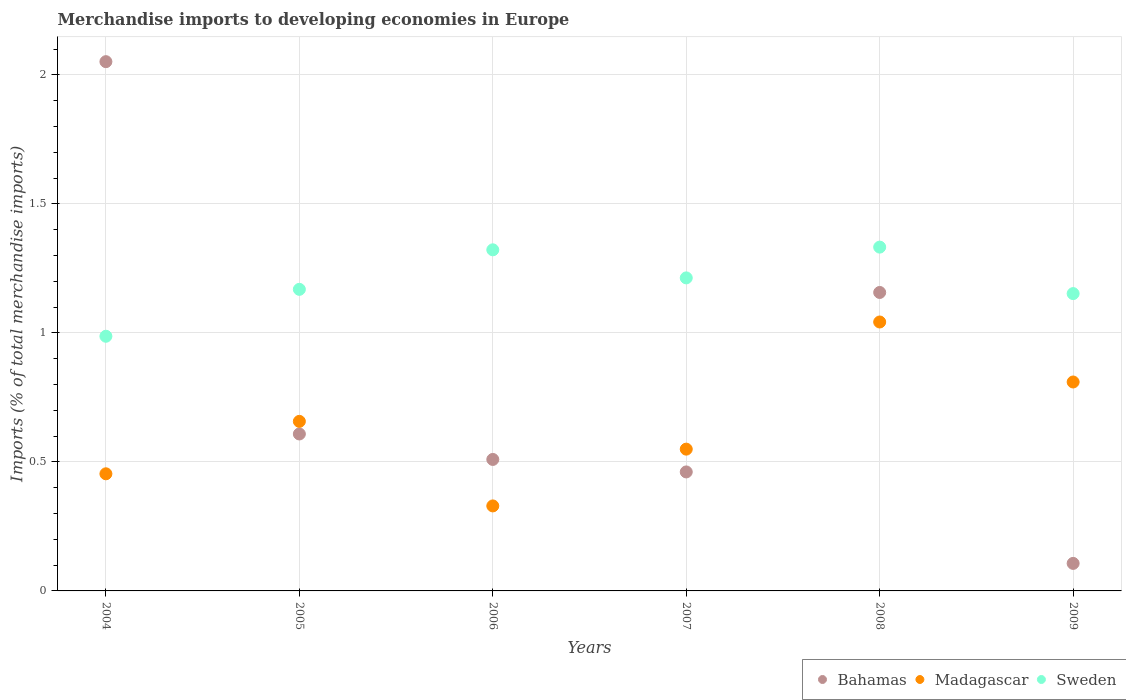Is the number of dotlines equal to the number of legend labels?
Your answer should be very brief. Yes. What is the percentage total merchandise imports in Sweden in 2007?
Provide a succinct answer. 1.21. Across all years, what is the maximum percentage total merchandise imports in Sweden?
Provide a succinct answer. 1.33. Across all years, what is the minimum percentage total merchandise imports in Bahamas?
Provide a succinct answer. 0.11. In which year was the percentage total merchandise imports in Madagascar maximum?
Give a very brief answer. 2008. What is the total percentage total merchandise imports in Madagascar in the graph?
Make the answer very short. 3.84. What is the difference between the percentage total merchandise imports in Sweden in 2007 and that in 2009?
Your answer should be compact. 0.06. What is the difference between the percentage total merchandise imports in Sweden in 2005 and the percentage total merchandise imports in Madagascar in 2007?
Offer a very short reply. 0.62. What is the average percentage total merchandise imports in Bahamas per year?
Offer a terse response. 0.82. In the year 2007, what is the difference between the percentage total merchandise imports in Sweden and percentage total merchandise imports in Bahamas?
Provide a succinct answer. 0.75. What is the ratio of the percentage total merchandise imports in Sweden in 2005 to that in 2007?
Provide a short and direct response. 0.96. Is the percentage total merchandise imports in Sweden in 2004 less than that in 2007?
Ensure brevity in your answer.  Yes. Is the difference between the percentage total merchandise imports in Sweden in 2006 and 2007 greater than the difference between the percentage total merchandise imports in Bahamas in 2006 and 2007?
Make the answer very short. Yes. What is the difference between the highest and the second highest percentage total merchandise imports in Sweden?
Your answer should be compact. 0.01. What is the difference between the highest and the lowest percentage total merchandise imports in Sweden?
Your response must be concise. 0.35. In how many years, is the percentage total merchandise imports in Madagascar greater than the average percentage total merchandise imports in Madagascar taken over all years?
Offer a terse response. 3. Is the sum of the percentage total merchandise imports in Sweden in 2005 and 2008 greater than the maximum percentage total merchandise imports in Bahamas across all years?
Your answer should be very brief. Yes. Is it the case that in every year, the sum of the percentage total merchandise imports in Madagascar and percentage total merchandise imports in Bahamas  is greater than the percentage total merchandise imports in Sweden?
Give a very brief answer. No. Does the percentage total merchandise imports in Bahamas monotonically increase over the years?
Provide a short and direct response. No. Is the percentage total merchandise imports in Sweden strictly greater than the percentage total merchandise imports in Bahamas over the years?
Your answer should be very brief. No. How many years are there in the graph?
Your answer should be compact. 6. What is the difference between two consecutive major ticks on the Y-axis?
Your response must be concise. 0.5. Are the values on the major ticks of Y-axis written in scientific E-notation?
Your answer should be very brief. No. Where does the legend appear in the graph?
Give a very brief answer. Bottom right. How many legend labels are there?
Ensure brevity in your answer.  3. How are the legend labels stacked?
Your answer should be very brief. Horizontal. What is the title of the graph?
Offer a very short reply. Merchandise imports to developing economies in Europe. Does "Bermuda" appear as one of the legend labels in the graph?
Provide a succinct answer. No. What is the label or title of the X-axis?
Offer a very short reply. Years. What is the label or title of the Y-axis?
Your answer should be compact. Imports (% of total merchandise imports). What is the Imports (% of total merchandise imports) in Bahamas in 2004?
Your response must be concise. 2.05. What is the Imports (% of total merchandise imports) of Madagascar in 2004?
Give a very brief answer. 0.45. What is the Imports (% of total merchandise imports) in Sweden in 2004?
Ensure brevity in your answer.  0.99. What is the Imports (% of total merchandise imports) of Bahamas in 2005?
Provide a short and direct response. 0.61. What is the Imports (% of total merchandise imports) of Madagascar in 2005?
Keep it short and to the point. 0.66. What is the Imports (% of total merchandise imports) of Sweden in 2005?
Ensure brevity in your answer.  1.17. What is the Imports (% of total merchandise imports) of Bahamas in 2006?
Make the answer very short. 0.51. What is the Imports (% of total merchandise imports) in Madagascar in 2006?
Keep it short and to the point. 0.33. What is the Imports (% of total merchandise imports) of Sweden in 2006?
Ensure brevity in your answer.  1.32. What is the Imports (% of total merchandise imports) of Bahamas in 2007?
Give a very brief answer. 0.46. What is the Imports (% of total merchandise imports) of Madagascar in 2007?
Give a very brief answer. 0.55. What is the Imports (% of total merchandise imports) of Sweden in 2007?
Provide a succinct answer. 1.21. What is the Imports (% of total merchandise imports) in Bahamas in 2008?
Offer a very short reply. 1.16. What is the Imports (% of total merchandise imports) in Madagascar in 2008?
Offer a very short reply. 1.04. What is the Imports (% of total merchandise imports) of Sweden in 2008?
Offer a very short reply. 1.33. What is the Imports (% of total merchandise imports) of Bahamas in 2009?
Offer a terse response. 0.11. What is the Imports (% of total merchandise imports) of Madagascar in 2009?
Your answer should be compact. 0.81. What is the Imports (% of total merchandise imports) in Sweden in 2009?
Your answer should be compact. 1.15. Across all years, what is the maximum Imports (% of total merchandise imports) of Bahamas?
Give a very brief answer. 2.05. Across all years, what is the maximum Imports (% of total merchandise imports) in Madagascar?
Offer a terse response. 1.04. Across all years, what is the maximum Imports (% of total merchandise imports) of Sweden?
Your response must be concise. 1.33. Across all years, what is the minimum Imports (% of total merchandise imports) of Bahamas?
Your answer should be very brief. 0.11. Across all years, what is the minimum Imports (% of total merchandise imports) of Madagascar?
Ensure brevity in your answer.  0.33. Across all years, what is the minimum Imports (% of total merchandise imports) of Sweden?
Provide a short and direct response. 0.99. What is the total Imports (% of total merchandise imports) of Bahamas in the graph?
Offer a very short reply. 4.89. What is the total Imports (% of total merchandise imports) in Madagascar in the graph?
Provide a succinct answer. 3.84. What is the total Imports (% of total merchandise imports) in Sweden in the graph?
Your response must be concise. 7.18. What is the difference between the Imports (% of total merchandise imports) in Bahamas in 2004 and that in 2005?
Provide a short and direct response. 1.44. What is the difference between the Imports (% of total merchandise imports) of Madagascar in 2004 and that in 2005?
Keep it short and to the point. -0.2. What is the difference between the Imports (% of total merchandise imports) in Sweden in 2004 and that in 2005?
Offer a very short reply. -0.18. What is the difference between the Imports (% of total merchandise imports) of Bahamas in 2004 and that in 2006?
Ensure brevity in your answer.  1.54. What is the difference between the Imports (% of total merchandise imports) in Madagascar in 2004 and that in 2006?
Make the answer very short. 0.12. What is the difference between the Imports (% of total merchandise imports) of Sweden in 2004 and that in 2006?
Make the answer very short. -0.34. What is the difference between the Imports (% of total merchandise imports) in Bahamas in 2004 and that in 2007?
Provide a short and direct response. 1.59. What is the difference between the Imports (% of total merchandise imports) in Madagascar in 2004 and that in 2007?
Your answer should be very brief. -0.1. What is the difference between the Imports (% of total merchandise imports) in Sweden in 2004 and that in 2007?
Provide a short and direct response. -0.23. What is the difference between the Imports (% of total merchandise imports) of Bahamas in 2004 and that in 2008?
Offer a very short reply. 0.89. What is the difference between the Imports (% of total merchandise imports) of Madagascar in 2004 and that in 2008?
Offer a very short reply. -0.59. What is the difference between the Imports (% of total merchandise imports) in Sweden in 2004 and that in 2008?
Keep it short and to the point. -0.35. What is the difference between the Imports (% of total merchandise imports) in Bahamas in 2004 and that in 2009?
Provide a short and direct response. 1.94. What is the difference between the Imports (% of total merchandise imports) of Madagascar in 2004 and that in 2009?
Your answer should be very brief. -0.36. What is the difference between the Imports (% of total merchandise imports) in Sweden in 2004 and that in 2009?
Offer a terse response. -0.17. What is the difference between the Imports (% of total merchandise imports) in Bahamas in 2005 and that in 2006?
Offer a very short reply. 0.1. What is the difference between the Imports (% of total merchandise imports) of Madagascar in 2005 and that in 2006?
Your answer should be compact. 0.33. What is the difference between the Imports (% of total merchandise imports) of Sweden in 2005 and that in 2006?
Give a very brief answer. -0.15. What is the difference between the Imports (% of total merchandise imports) of Bahamas in 2005 and that in 2007?
Your answer should be compact. 0.15. What is the difference between the Imports (% of total merchandise imports) in Madagascar in 2005 and that in 2007?
Your answer should be very brief. 0.11. What is the difference between the Imports (% of total merchandise imports) of Sweden in 2005 and that in 2007?
Offer a very short reply. -0.04. What is the difference between the Imports (% of total merchandise imports) in Bahamas in 2005 and that in 2008?
Provide a succinct answer. -0.55. What is the difference between the Imports (% of total merchandise imports) in Madagascar in 2005 and that in 2008?
Your answer should be compact. -0.39. What is the difference between the Imports (% of total merchandise imports) of Sweden in 2005 and that in 2008?
Your response must be concise. -0.16. What is the difference between the Imports (% of total merchandise imports) in Bahamas in 2005 and that in 2009?
Your answer should be compact. 0.5. What is the difference between the Imports (% of total merchandise imports) in Madagascar in 2005 and that in 2009?
Offer a terse response. -0.15. What is the difference between the Imports (% of total merchandise imports) of Sweden in 2005 and that in 2009?
Your response must be concise. 0.02. What is the difference between the Imports (% of total merchandise imports) in Bahamas in 2006 and that in 2007?
Offer a very short reply. 0.05. What is the difference between the Imports (% of total merchandise imports) of Madagascar in 2006 and that in 2007?
Your answer should be compact. -0.22. What is the difference between the Imports (% of total merchandise imports) of Sweden in 2006 and that in 2007?
Offer a very short reply. 0.11. What is the difference between the Imports (% of total merchandise imports) in Bahamas in 2006 and that in 2008?
Give a very brief answer. -0.65. What is the difference between the Imports (% of total merchandise imports) of Madagascar in 2006 and that in 2008?
Your response must be concise. -0.71. What is the difference between the Imports (% of total merchandise imports) of Sweden in 2006 and that in 2008?
Provide a succinct answer. -0.01. What is the difference between the Imports (% of total merchandise imports) in Bahamas in 2006 and that in 2009?
Provide a short and direct response. 0.4. What is the difference between the Imports (% of total merchandise imports) of Madagascar in 2006 and that in 2009?
Offer a terse response. -0.48. What is the difference between the Imports (% of total merchandise imports) in Sweden in 2006 and that in 2009?
Offer a terse response. 0.17. What is the difference between the Imports (% of total merchandise imports) of Bahamas in 2007 and that in 2008?
Provide a short and direct response. -0.7. What is the difference between the Imports (% of total merchandise imports) in Madagascar in 2007 and that in 2008?
Ensure brevity in your answer.  -0.49. What is the difference between the Imports (% of total merchandise imports) in Sweden in 2007 and that in 2008?
Your answer should be very brief. -0.12. What is the difference between the Imports (% of total merchandise imports) in Bahamas in 2007 and that in 2009?
Your answer should be very brief. 0.35. What is the difference between the Imports (% of total merchandise imports) in Madagascar in 2007 and that in 2009?
Give a very brief answer. -0.26. What is the difference between the Imports (% of total merchandise imports) of Sweden in 2007 and that in 2009?
Offer a very short reply. 0.06. What is the difference between the Imports (% of total merchandise imports) of Bahamas in 2008 and that in 2009?
Provide a succinct answer. 1.05. What is the difference between the Imports (% of total merchandise imports) of Madagascar in 2008 and that in 2009?
Your answer should be very brief. 0.23. What is the difference between the Imports (% of total merchandise imports) in Sweden in 2008 and that in 2009?
Your response must be concise. 0.18. What is the difference between the Imports (% of total merchandise imports) in Bahamas in 2004 and the Imports (% of total merchandise imports) in Madagascar in 2005?
Provide a succinct answer. 1.39. What is the difference between the Imports (% of total merchandise imports) of Bahamas in 2004 and the Imports (% of total merchandise imports) of Sweden in 2005?
Offer a terse response. 0.88. What is the difference between the Imports (% of total merchandise imports) in Madagascar in 2004 and the Imports (% of total merchandise imports) in Sweden in 2005?
Provide a succinct answer. -0.71. What is the difference between the Imports (% of total merchandise imports) in Bahamas in 2004 and the Imports (% of total merchandise imports) in Madagascar in 2006?
Your response must be concise. 1.72. What is the difference between the Imports (% of total merchandise imports) in Bahamas in 2004 and the Imports (% of total merchandise imports) in Sweden in 2006?
Your response must be concise. 0.73. What is the difference between the Imports (% of total merchandise imports) of Madagascar in 2004 and the Imports (% of total merchandise imports) of Sweden in 2006?
Provide a short and direct response. -0.87. What is the difference between the Imports (% of total merchandise imports) in Bahamas in 2004 and the Imports (% of total merchandise imports) in Madagascar in 2007?
Provide a short and direct response. 1.5. What is the difference between the Imports (% of total merchandise imports) in Bahamas in 2004 and the Imports (% of total merchandise imports) in Sweden in 2007?
Provide a short and direct response. 0.84. What is the difference between the Imports (% of total merchandise imports) of Madagascar in 2004 and the Imports (% of total merchandise imports) of Sweden in 2007?
Your response must be concise. -0.76. What is the difference between the Imports (% of total merchandise imports) of Bahamas in 2004 and the Imports (% of total merchandise imports) of Madagascar in 2008?
Provide a succinct answer. 1.01. What is the difference between the Imports (% of total merchandise imports) of Bahamas in 2004 and the Imports (% of total merchandise imports) of Sweden in 2008?
Ensure brevity in your answer.  0.72. What is the difference between the Imports (% of total merchandise imports) of Madagascar in 2004 and the Imports (% of total merchandise imports) of Sweden in 2008?
Provide a short and direct response. -0.88. What is the difference between the Imports (% of total merchandise imports) in Bahamas in 2004 and the Imports (% of total merchandise imports) in Madagascar in 2009?
Provide a succinct answer. 1.24. What is the difference between the Imports (% of total merchandise imports) of Bahamas in 2004 and the Imports (% of total merchandise imports) of Sweden in 2009?
Offer a very short reply. 0.9. What is the difference between the Imports (% of total merchandise imports) in Madagascar in 2004 and the Imports (% of total merchandise imports) in Sweden in 2009?
Make the answer very short. -0.7. What is the difference between the Imports (% of total merchandise imports) in Bahamas in 2005 and the Imports (% of total merchandise imports) in Madagascar in 2006?
Ensure brevity in your answer.  0.28. What is the difference between the Imports (% of total merchandise imports) of Bahamas in 2005 and the Imports (% of total merchandise imports) of Sweden in 2006?
Your answer should be compact. -0.71. What is the difference between the Imports (% of total merchandise imports) of Madagascar in 2005 and the Imports (% of total merchandise imports) of Sweden in 2006?
Make the answer very short. -0.66. What is the difference between the Imports (% of total merchandise imports) in Bahamas in 2005 and the Imports (% of total merchandise imports) in Madagascar in 2007?
Offer a very short reply. 0.06. What is the difference between the Imports (% of total merchandise imports) of Bahamas in 2005 and the Imports (% of total merchandise imports) of Sweden in 2007?
Provide a short and direct response. -0.6. What is the difference between the Imports (% of total merchandise imports) in Madagascar in 2005 and the Imports (% of total merchandise imports) in Sweden in 2007?
Make the answer very short. -0.56. What is the difference between the Imports (% of total merchandise imports) in Bahamas in 2005 and the Imports (% of total merchandise imports) in Madagascar in 2008?
Offer a terse response. -0.43. What is the difference between the Imports (% of total merchandise imports) in Bahamas in 2005 and the Imports (% of total merchandise imports) in Sweden in 2008?
Your answer should be compact. -0.72. What is the difference between the Imports (% of total merchandise imports) of Madagascar in 2005 and the Imports (% of total merchandise imports) of Sweden in 2008?
Your response must be concise. -0.68. What is the difference between the Imports (% of total merchandise imports) of Bahamas in 2005 and the Imports (% of total merchandise imports) of Madagascar in 2009?
Ensure brevity in your answer.  -0.2. What is the difference between the Imports (% of total merchandise imports) of Bahamas in 2005 and the Imports (% of total merchandise imports) of Sweden in 2009?
Your answer should be very brief. -0.54. What is the difference between the Imports (% of total merchandise imports) in Madagascar in 2005 and the Imports (% of total merchandise imports) in Sweden in 2009?
Your answer should be compact. -0.5. What is the difference between the Imports (% of total merchandise imports) in Bahamas in 2006 and the Imports (% of total merchandise imports) in Madagascar in 2007?
Your answer should be very brief. -0.04. What is the difference between the Imports (% of total merchandise imports) of Bahamas in 2006 and the Imports (% of total merchandise imports) of Sweden in 2007?
Make the answer very short. -0.7. What is the difference between the Imports (% of total merchandise imports) in Madagascar in 2006 and the Imports (% of total merchandise imports) in Sweden in 2007?
Make the answer very short. -0.88. What is the difference between the Imports (% of total merchandise imports) of Bahamas in 2006 and the Imports (% of total merchandise imports) of Madagascar in 2008?
Ensure brevity in your answer.  -0.53. What is the difference between the Imports (% of total merchandise imports) in Bahamas in 2006 and the Imports (% of total merchandise imports) in Sweden in 2008?
Provide a succinct answer. -0.82. What is the difference between the Imports (% of total merchandise imports) in Madagascar in 2006 and the Imports (% of total merchandise imports) in Sweden in 2008?
Ensure brevity in your answer.  -1. What is the difference between the Imports (% of total merchandise imports) in Bahamas in 2006 and the Imports (% of total merchandise imports) in Madagascar in 2009?
Your answer should be compact. -0.3. What is the difference between the Imports (% of total merchandise imports) in Bahamas in 2006 and the Imports (% of total merchandise imports) in Sweden in 2009?
Ensure brevity in your answer.  -0.64. What is the difference between the Imports (% of total merchandise imports) of Madagascar in 2006 and the Imports (% of total merchandise imports) of Sweden in 2009?
Provide a succinct answer. -0.82. What is the difference between the Imports (% of total merchandise imports) of Bahamas in 2007 and the Imports (% of total merchandise imports) of Madagascar in 2008?
Offer a terse response. -0.58. What is the difference between the Imports (% of total merchandise imports) in Bahamas in 2007 and the Imports (% of total merchandise imports) in Sweden in 2008?
Offer a terse response. -0.87. What is the difference between the Imports (% of total merchandise imports) in Madagascar in 2007 and the Imports (% of total merchandise imports) in Sweden in 2008?
Offer a terse response. -0.78. What is the difference between the Imports (% of total merchandise imports) in Bahamas in 2007 and the Imports (% of total merchandise imports) in Madagascar in 2009?
Provide a succinct answer. -0.35. What is the difference between the Imports (% of total merchandise imports) in Bahamas in 2007 and the Imports (% of total merchandise imports) in Sweden in 2009?
Your answer should be compact. -0.69. What is the difference between the Imports (% of total merchandise imports) in Madagascar in 2007 and the Imports (% of total merchandise imports) in Sweden in 2009?
Keep it short and to the point. -0.6. What is the difference between the Imports (% of total merchandise imports) of Bahamas in 2008 and the Imports (% of total merchandise imports) of Madagascar in 2009?
Provide a short and direct response. 0.35. What is the difference between the Imports (% of total merchandise imports) in Bahamas in 2008 and the Imports (% of total merchandise imports) in Sweden in 2009?
Provide a succinct answer. 0. What is the difference between the Imports (% of total merchandise imports) in Madagascar in 2008 and the Imports (% of total merchandise imports) in Sweden in 2009?
Provide a short and direct response. -0.11. What is the average Imports (% of total merchandise imports) in Bahamas per year?
Offer a terse response. 0.82. What is the average Imports (% of total merchandise imports) of Madagascar per year?
Your answer should be very brief. 0.64. What is the average Imports (% of total merchandise imports) in Sweden per year?
Provide a succinct answer. 1.2. In the year 2004, what is the difference between the Imports (% of total merchandise imports) of Bahamas and Imports (% of total merchandise imports) of Madagascar?
Offer a terse response. 1.6. In the year 2004, what is the difference between the Imports (% of total merchandise imports) of Bahamas and Imports (% of total merchandise imports) of Sweden?
Offer a very short reply. 1.06. In the year 2004, what is the difference between the Imports (% of total merchandise imports) in Madagascar and Imports (% of total merchandise imports) in Sweden?
Offer a terse response. -0.53. In the year 2005, what is the difference between the Imports (% of total merchandise imports) in Bahamas and Imports (% of total merchandise imports) in Madagascar?
Offer a terse response. -0.05. In the year 2005, what is the difference between the Imports (% of total merchandise imports) of Bahamas and Imports (% of total merchandise imports) of Sweden?
Your answer should be very brief. -0.56. In the year 2005, what is the difference between the Imports (% of total merchandise imports) of Madagascar and Imports (% of total merchandise imports) of Sweden?
Your response must be concise. -0.51. In the year 2006, what is the difference between the Imports (% of total merchandise imports) in Bahamas and Imports (% of total merchandise imports) in Madagascar?
Your answer should be very brief. 0.18. In the year 2006, what is the difference between the Imports (% of total merchandise imports) in Bahamas and Imports (% of total merchandise imports) in Sweden?
Keep it short and to the point. -0.81. In the year 2006, what is the difference between the Imports (% of total merchandise imports) of Madagascar and Imports (% of total merchandise imports) of Sweden?
Give a very brief answer. -0.99. In the year 2007, what is the difference between the Imports (% of total merchandise imports) of Bahamas and Imports (% of total merchandise imports) of Madagascar?
Your response must be concise. -0.09. In the year 2007, what is the difference between the Imports (% of total merchandise imports) of Bahamas and Imports (% of total merchandise imports) of Sweden?
Ensure brevity in your answer.  -0.75. In the year 2007, what is the difference between the Imports (% of total merchandise imports) in Madagascar and Imports (% of total merchandise imports) in Sweden?
Provide a succinct answer. -0.66. In the year 2008, what is the difference between the Imports (% of total merchandise imports) in Bahamas and Imports (% of total merchandise imports) in Madagascar?
Your answer should be compact. 0.11. In the year 2008, what is the difference between the Imports (% of total merchandise imports) in Bahamas and Imports (% of total merchandise imports) in Sweden?
Make the answer very short. -0.18. In the year 2008, what is the difference between the Imports (% of total merchandise imports) in Madagascar and Imports (% of total merchandise imports) in Sweden?
Make the answer very short. -0.29. In the year 2009, what is the difference between the Imports (% of total merchandise imports) in Bahamas and Imports (% of total merchandise imports) in Madagascar?
Keep it short and to the point. -0.7. In the year 2009, what is the difference between the Imports (% of total merchandise imports) of Bahamas and Imports (% of total merchandise imports) of Sweden?
Provide a succinct answer. -1.05. In the year 2009, what is the difference between the Imports (% of total merchandise imports) in Madagascar and Imports (% of total merchandise imports) in Sweden?
Provide a succinct answer. -0.34. What is the ratio of the Imports (% of total merchandise imports) of Bahamas in 2004 to that in 2005?
Make the answer very short. 3.37. What is the ratio of the Imports (% of total merchandise imports) in Madagascar in 2004 to that in 2005?
Offer a terse response. 0.69. What is the ratio of the Imports (% of total merchandise imports) in Sweden in 2004 to that in 2005?
Your response must be concise. 0.84. What is the ratio of the Imports (% of total merchandise imports) of Bahamas in 2004 to that in 2006?
Ensure brevity in your answer.  4.03. What is the ratio of the Imports (% of total merchandise imports) in Madagascar in 2004 to that in 2006?
Offer a very short reply. 1.38. What is the ratio of the Imports (% of total merchandise imports) in Sweden in 2004 to that in 2006?
Offer a very short reply. 0.75. What is the ratio of the Imports (% of total merchandise imports) of Bahamas in 2004 to that in 2007?
Give a very brief answer. 4.45. What is the ratio of the Imports (% of total merchandise imports) of Madagascar in 2004 to that in 2007?
Provide a succinct answer. 0.83. What is the ratio of the Imports (% of total merchandise imports) of Sweden in 2004 to that in 2007?
Keep it short and to the point. 0.81. What is the ratio of the Imports (% of total merchandise imports) in Bahamas in 2004 to that in 2008?
Offer a terse response. 1.77. What is the ratio of the Imports (% of total merchandise imports) in Madagascar in 2004 to that in 2008?
Your answer should be compact. 0.44. What is the ratio of the Imports (% of total merchandise imports) in Sweden in 2004 to that in 2008?
Provide a short and direct response. 0.74. What is the ratio of the Imports (% of total merchandise imports) in Bahamas in 2004 to that in 2009?
Give a very brief answer. 19.23. What is the ratio of the Imports (% of total merchandise imports) of Madagascar in 2004 to that in 2009?
Provide a short and direct response. 0.56. What is the ratio of the Imports (% of total merchandise imports) in Sweden in 2004 to that in 2009?
Your answer should be very brief. 0.86. What is the ratio of the Imports (% of total merchandise imports) of Bahamas in 2005 to that in 2006?
Your answer should be compact. 1.19. What is the ratio of the Imports (% of total merchandise imports) in Madagascar in 2005 to that in 2006?
Provide a succinct answer. 1.99. What is the ratio of the Imports (% of total merchandise imports) in Sweden in 2005 to that in 2006?
Your answer should be compact. 0.88. What is the ratio of the Imports (% of total merchandise imports) of Bahamas in 2005 to that in 2007?
Keep it short and to the point. 1.32. What is the ratio of the Imports (% of total merchandise imports) of Madagascar in 2005 to that in 2007?
Your response must be concise. 1.2. What is the ratio of the Imports (% of total merchandise imports) of Sweden in 2005 to that in 2007?
Make the answer very short. 0.96. What is the ratio of the Imports (% of total merchandise imports) of Bahamas in 2005 to that in 2008?
Your answer should be compact. 0.53. What is the ratio of the Imports (% of total merchandise imports) of Madagascar in 2005 to that in 2008?
Offer a very short reply. 0.63. What is the ratio of the Imports (% of total merchandise imports) of Sweden in 2005 to that in 2008?
Give a very brief answer. 0.88. What is the ratio of the Imports (% of total merchandise imports) in Bahamas in 2005 to that in 2009?
Ensure brevity in your answer.  5.7. What is the ratio of the Imports (% of total merchandise imports) of Madagascar in 2005 to that in 2009?
Keep it short and to the point. 0.81. What is the ratio of the Imports (% of total merchandise imports) in Sweden in 2005 to that in 2009?
Provide a succinct answer. 1.01. What is the ratio of the Imports (% of total merchandise imports) in Bahamas in 2006 to that in 2007?
Make the answer very short. 1.1. What is the ratio of the Imports (% of total merchandise imports) in Madagascar in 2006 to that in 2007?
Provide a succinct answer. 0.6. What is the ratio of the Imports (% of total merchandise imports) of Sweden in 2006 to that in 2007?
Your response must be concise. 1.09. What is the ratio of the Imports (% of total merchandise imports) in Bahamas in 2006 to that in 2008?
Your answer should be compact. 0.44. What is the ratio of the Imports (% of total merchandise imports) of Madagascar in 2006 to that in 2008?
Ensure brevity in your answer.  0.32. What is the ratio of the Imports (% of total merchandise imports) of Bahamas in 2006 to that in 2009?
Provide a succinct answer. 4.78. What is the ratio of the Imports (% of total merchandise imports) in Madagascar in 2006 to that in 2009?
Provide a succinct answer. 0.41. What is the ratio of the Imports (% of total merchandise imports) of Sweden in 2006 to that in 2009?
Offer a terse response. 1.15. What is the ratio of the Imports (% of total merchandise imports) in Bahamas in 2007 to that in 2008?
Your response must be concise. 0.4. What is the ratio of the Imports (% of total merchandise imports) in Madagascar in 2007 to that in 2008?
Provide a succinct answer. 0.53. What is the ratio of the Imports (% of total merchandise imports) of Sweden in 2007 to that in 2008?
Your response must be concise. 0.91. What is the ratio of the Imports (% of total merchandise imports) of Bahamas in 2007 to that in 2009?
Your response must be concise. 4.32. What is the ratio of the Imports (% of total merchandise imports) in Madagascar in 2007 to that in 2009?
Your answer should be very brief. 0.68. What is the ratio of the Imports (% of total merchandise imports) of Sweden in 2007 to that in 2009?
Offer a terse response. 1.05. What is the ratio of the Imports (% of total merchandise imports) in Bahamas in 2008 to that in 2009?
Your answer should be compact. 10.84. What is the ratio of the Imports (% of total merchandise imports) of Madagascar in 2008 to that in 2009?
Make the answer very short. 1.29. What is the ratio of the Imports (% of total merchandise imports) in Sweden in 2008 to that in 2009?
Your answer should be compact. 1.16. What is the difference between the highest and the second highest Imports (% of total merchandise imports) of Bahamas?
Offer a very short reply. 0.89. What is the difference between the highest and the second highest Imports (% of total merchandise imports) of Madagascar?
Your response must be concise. 0.23. What is the difference between the highest and the second highest Imports (% of total merchandise imports) in Sweden?
Your answer should be compact. 0.01. What is the difference between the highest and the lowest Imports (% of total merchandise imports) in Bahamas?
Your answer should be very brief. 1.94. What is the difference between the highest and the lowest Imports (% of total merchandise imports) in Madagascar?
Keep it short and to the point. 0.71. What is the difference between the highest and the lowest Imports (% of total merchandise imports) in Sweden?
Keep it short and to the point. 0.35. 